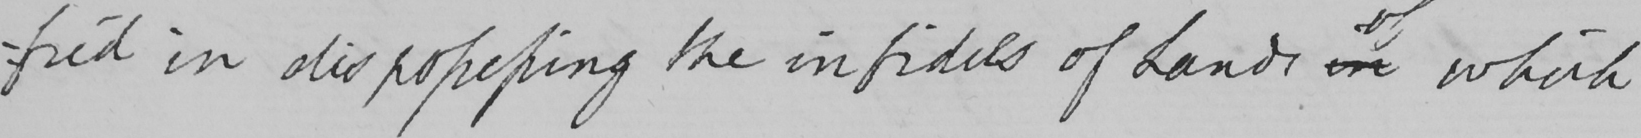What is written in this line of handwriting? -fied in dispossessing the infidels of Lands in which 